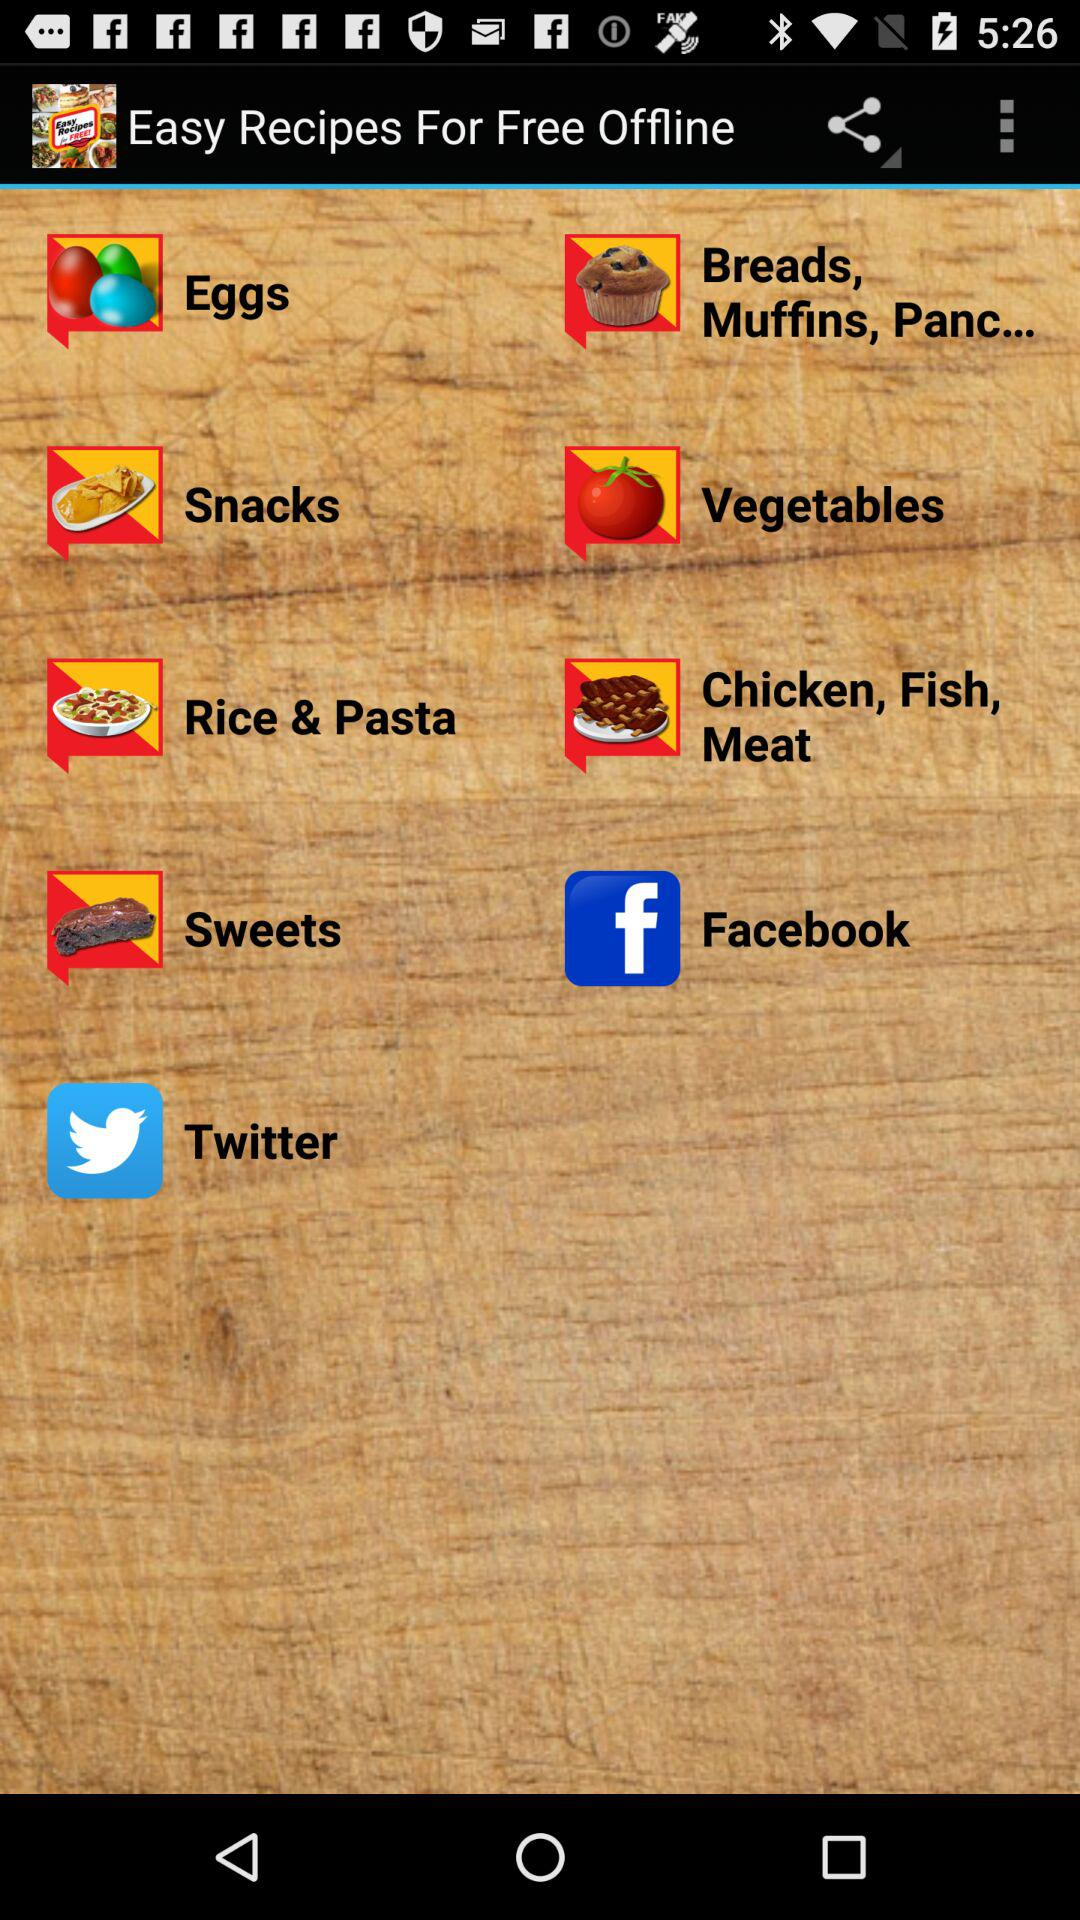What are the available items in "Easy Recipes For Free Offline"? The available items in "Easy Recipes For Free Offline" are "Eggs", "Breads, Muffins, Panc...", "Snacks", "Vegetables", "Rice & Pasta", "Chicken, Fish, Meat" and "Sweets". 